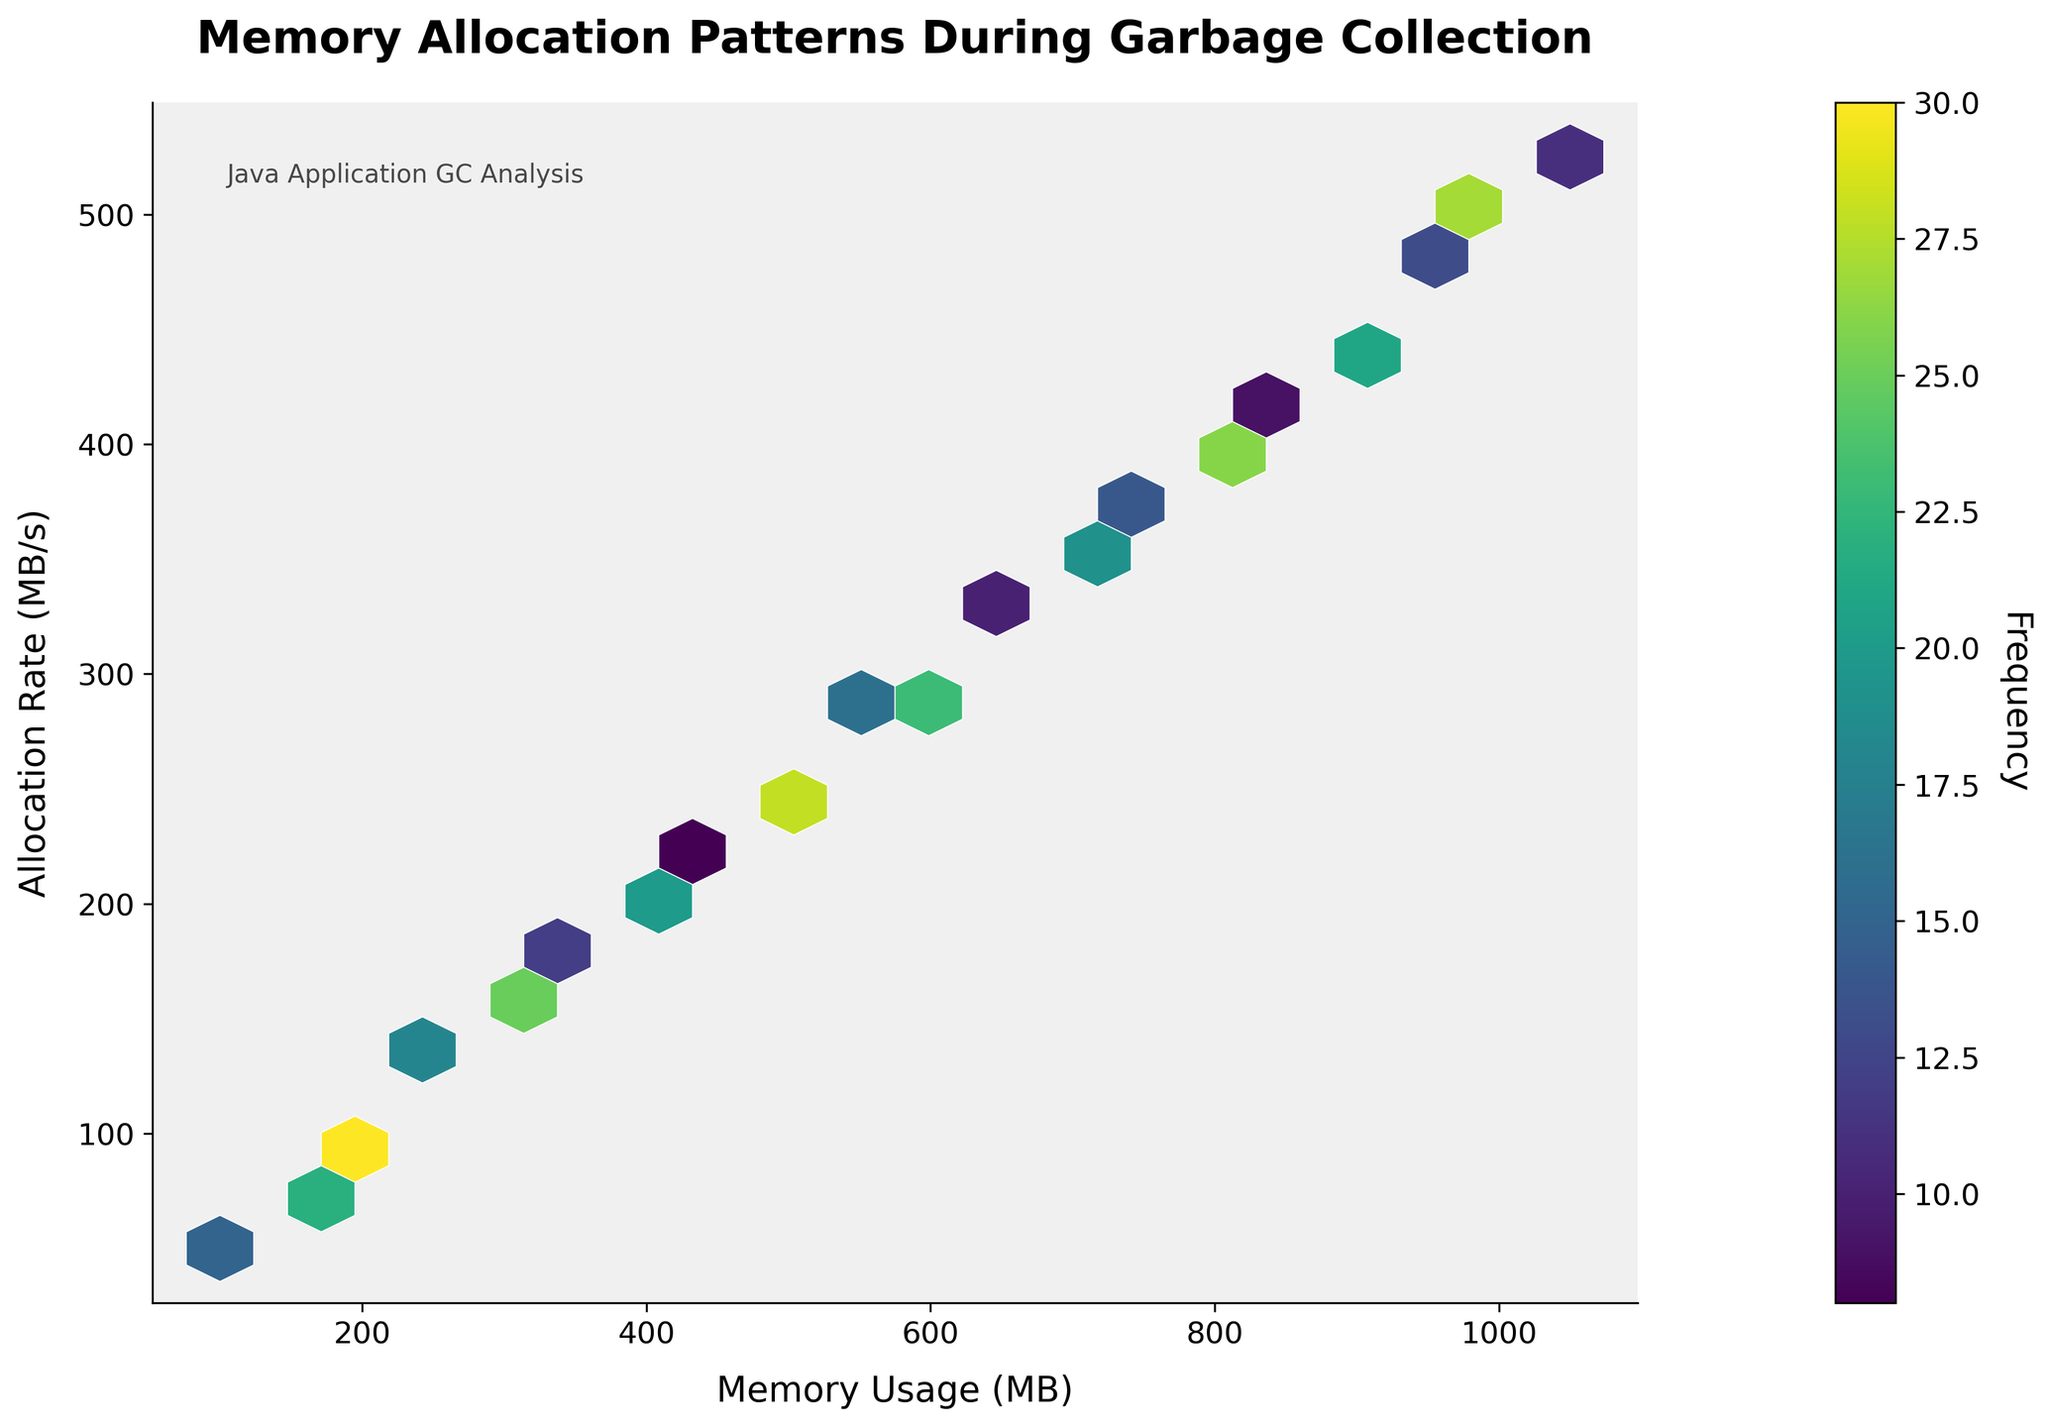What's the title of the figure? The title is written at the top of the figure in bold and large font size.
Answer: Memory Allocation Patterns During Garbage Collection What are the axes labels? The x-axis label is at the bottom, and the y-axis label is on the left side of the plot.
Answer: Memory Usage (MB) and Allocation Rate (MB/s) What's the color used for the plot background? The background color of the plot can be observed directly behind the hexagons.
Answer: Light gray What's the range of the color bar? The color bar represents frequency and the range can be seen by the color gradient from the bottom to the top.
Answer: 8 to 30 Which area of the plot has the highest frequency? The frequency is indicated by the darkest color in the hexbin plot. Identify the hexagon that appears the darkest.
Answer: (1000, 500) What is the most frequent memory allocation rate when memory usage is around 500 MB? Observe the y-coordinate where the hexagons are darkest around the x-coordinate of 500 MB.
Answer: 250 MB/s Compare the frequency of memory allocations at (200 MB, 100 MB/s) and (450 MB, 225 MB/s). Which one is higher? Check the color intensity of the hexagons; darker colors indicate higher frequency.
Answer: (200 MB, 100 MB/s) Estimate the average frequency of memory allocations for the highest memory usage. Identify the hexagon at the highest memory usage, note the color, and refer to the color bar to estimate the frequency.
Answer: 14 to 17 Which memory allocation rate has the least frequency? Locate the lightest colored hexagon and refer to its y-axis value.
Answer: 225 MB/s What's the color of the hexagons with counts between 20 and 25? Refer to the color gradient on the color bar between values 20 and 25 and identify its corresponding color.
Answer: Dark green to yellow 